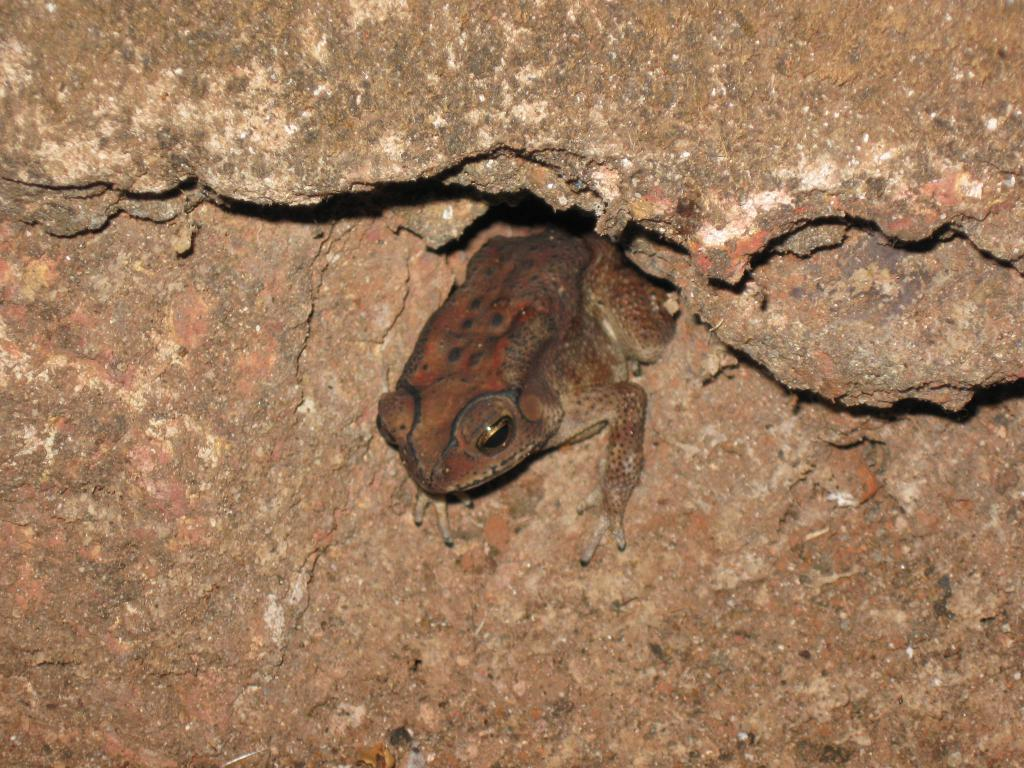What is the main subject in the center of the image? There is a rock in the center of the image. Is there anything on the rock? Yes, there is a frog on the rock. Where is the drawer located in the image? There is no drawer present in the image. What type of needle is being used by the coach in the image? There is no coach or needle present in the image. 